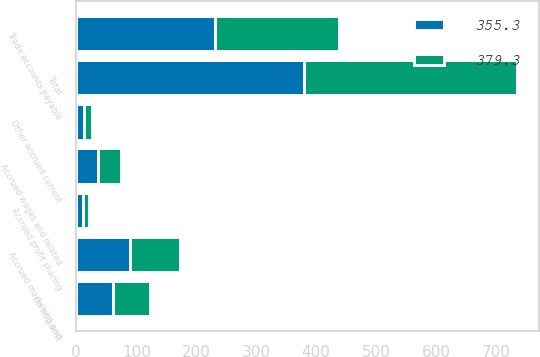Convert chart to OTSL. <chart><loc_0><loc_0><loc_500><loc_500><stacked_bar_chart><ecel><fcel>(In millions)<fcel>Trade accounts payable<fcel>Accrued marketing and<fcel>Accrued wages and related<fcel>Accrued profit sharing<fcel>Other accrued current<fcel>Total<nl><fcel>355.3<fcel>61.4<fcel>231.8<fcel>89<fcel>36<fcel>10.5<fcel>12<fcel>379.3<nl><fcel>379.3<fcel>61.4<fcel>206.3<fcel>83.9<fcel>38.9<fcel>11.5<fcel>14.7<fcel>355.3<nl></chart> 